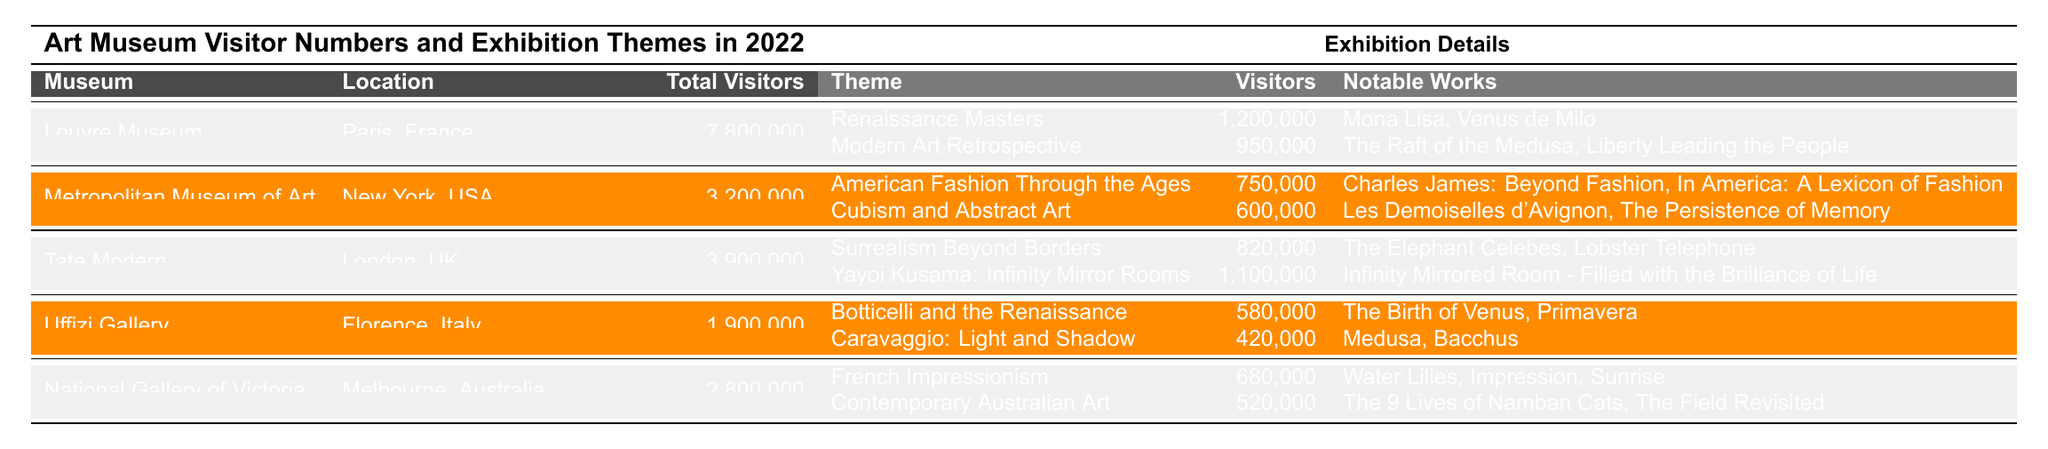What museum had the highest visitor numbers in 2022? The table shows that the Louvre Museum had 7,800,000 total visitors, which is more than any other museum listed.
Answer: Louvre Museum How many visitors did Tate Modern receive for the Yayoi Kusama exhibition? The table indicates that Tate Modern had 1,100,000 visitors for the Yayoi Kusama: Infinity Mirror Rooms exhibition.
Answer: 1,100,000 Which museum had fewer visitors than Uffizi Gallery? The Uffizi Gallery had 1,900,000 visitors; only the exhibitions of the Louvre Museum, Tate Modern, and National Gallery of Victoria had higher visitor numbers than that, while the Metropolitan Museum of Art had fewer visitors (3,200,000).
Answer: Metropolitan Museum of Art What was the total number of visitors to the National Gallery of Victoria's exhibitions? The National Gallery of Victoria had 680,000 visitors for French Impressionism and 520,000 for Contemporary Australian Art, totaling 1,200,000.
Answer: 1,200,000 Which exhibition theme attracted the most visitors at the Louvre Museum? The Renaissance Masters exhibition attracted 1,200,000 visitors, which is the highest among the themes listed for the Louvre Museum.
Answer: Renaissance Masters How do the total visitors of the Tate Modern compare to that of the Uffizi Gallery? Tate Modern had 3,900,000 visitors, while Uffizi Gallery had 1,900,000 visitors. The Tate Modern had 2,000,000 more visitors than the Uffizi Gallery.
Answer: 2,000,000 more Which exhibition featured notable works such as "The Birth of Venus" and "Primavera"? These notable works belong to the Botticelli and the Renaissance exhibition at the Uffizi Gallery.
Answer: Botticelli and the Renaissance What percentage of the total visitors at the Metropolitan Museum of Art attended the American Fashion Through the Ages exhibition? The American Fashion Through the Ages exhibition had 750,000 visitors out of a total of 3,200,000. Therefore, the percentage is (750,000 / 3,200,000) * 100 = 23.44%.
Answer: 23.44% Are there any exhibitions in the National Gallery of Victoria that had fewer visitors than the Uffizi Gallery's Caravaggio exhibition? The Caravaggio: Light and Shadow exhibition had 420,000 visitors, while Contemporary Australian Art in the National Gallery of Victoria had 520,000. Thus, there aren't any exhibitions in the National Gallery of Victoria with fewer visitors than the Caravaggio exhibition.
Answer: No Calculate the total number of visitors across all the museums listed in the table. The total visitors are: 7,800,000 (Louvre) + 3,200,000 (Metropolitan) + 3,900,000 (Tate) + 1,900,000 (Uffizi) + 2,800,000 (National Gallery of Victoria) = 19,600,000.
Answer: 19,600,000 